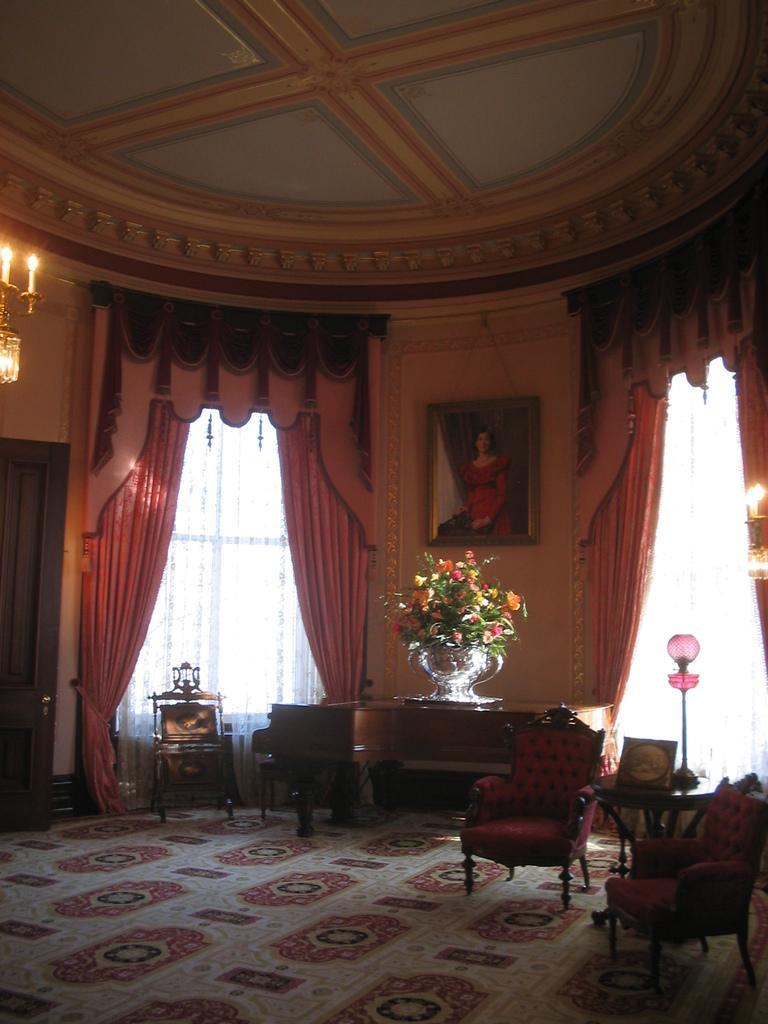Describe this image in one or two sentences. This picture is taken in a room, there is a carpet which is in white color, there are some chairs which are in red color, there is a table in the middle on that table there is a flower box which is in ash color, there are some curtains which are in red color and there is a picture in the middle on the wall. 